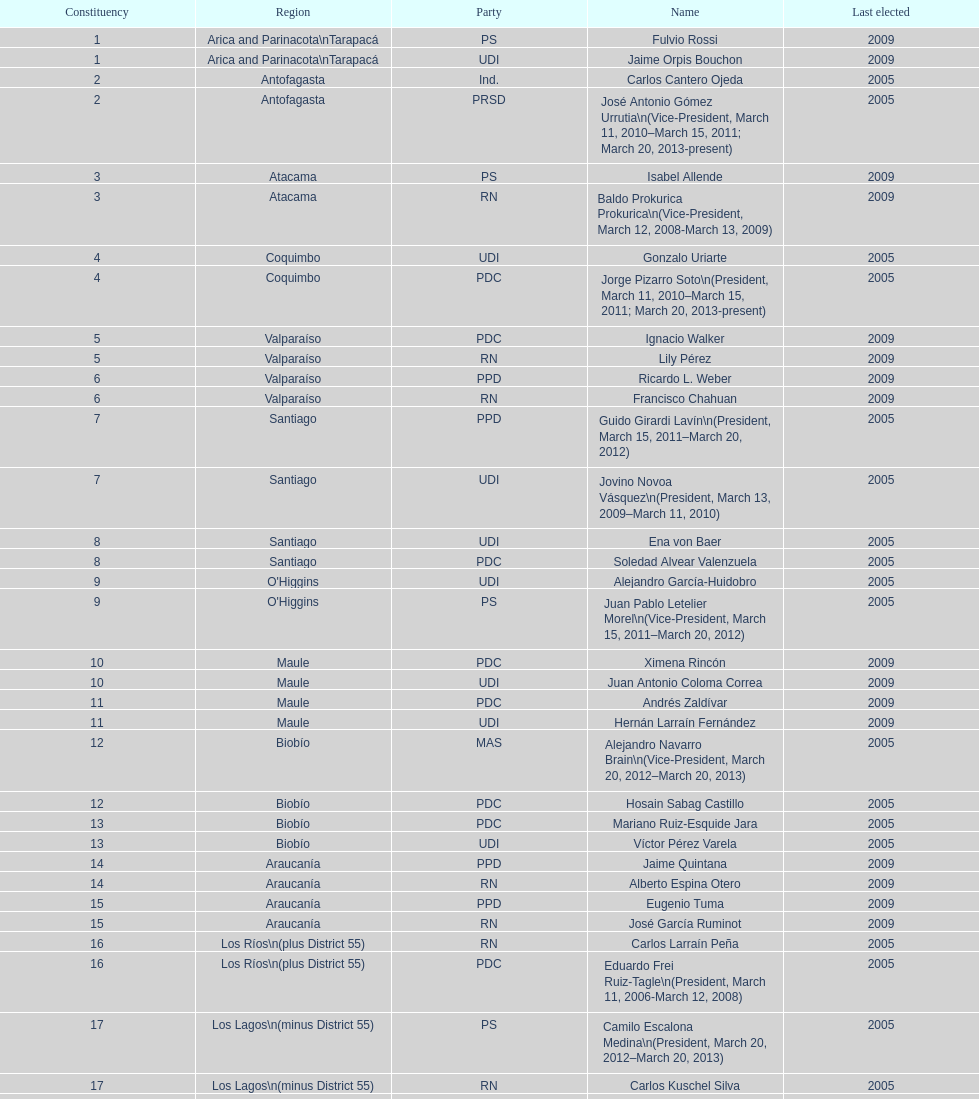When was antonio horvath kiss last elected? 2001. 